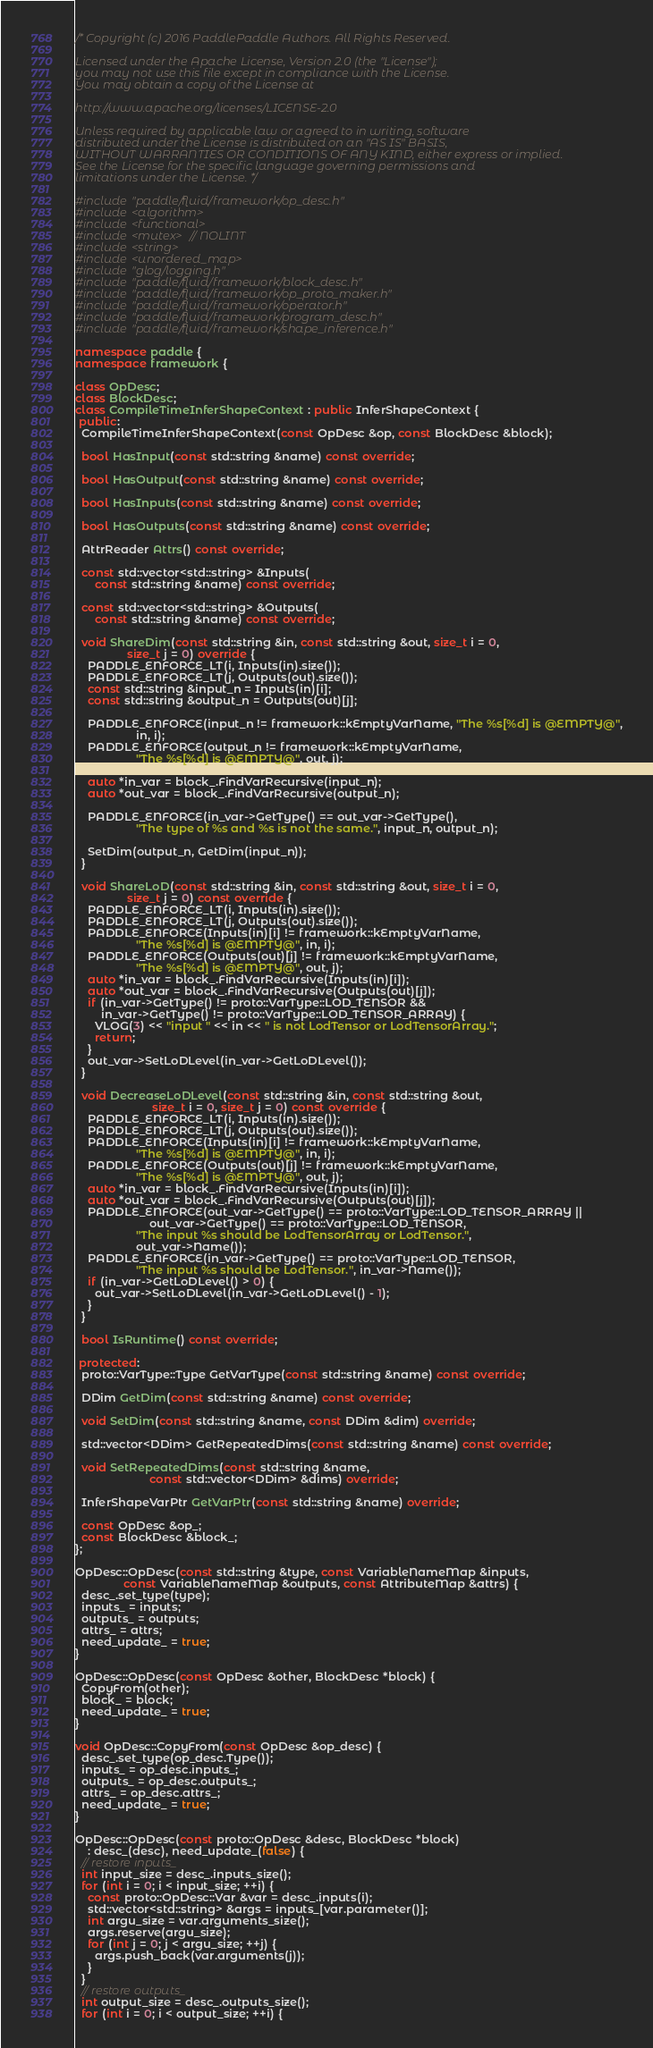<code> <loc_0><loc_0><loc_500><loc_500><_C++_>/* Copyright (c) 2016 PaddlePaddle Authors. All Rights Reserved.

Licensed under the Apache License, Version 2.0 (the "License");
you may not use this file except in compliance with the License.
You may obtain a copy of the License at

http://www.apache.org/licenses/LICENSE-2.0

Unless required by applicable law or agreed to in writing, software
distributed under the License is distributed on an "AS IS" BASIS,
WITHOUT WARRANTIES OR CONDITIONS OF ANY KIND, either express or implied.
See the License for the specific language governing permissions and
limitations under the License. */

#include "paddle/fluid/framework/op_desc.h"
#include <algorithm>
#include <functional>
#include <mutex>  // NOLINT
#include <string>
#include <unordered_map>
#include "glog/logging.h"
#include "paddle/fluid/framework/block_desc.h"
#include "paddle/fluid/framework/op_proto_maker.h"
#include "paddle/fluid/framework/operator.h"
#include "paddle/fluid/framework/program_desc.h"
#include "paddle/fluid/framework/shape_inference.h"

namespace paddle {
namespace framework {

class OpDesc;
class BlockDesc;
class CompileTimeInferShapeContext : public InferShapeContext {
 public:
  CompileTimeInferShapeContext(const OpDesc &op, const BlockDesc &block);

  bool HasInput(const std::string &name) const override;

  bool HasOutput(const std::string &name) const override;

  bool HasInputs(const std::string &name) const override;

  bool HasOutputs(const std::string &name) const override;

  AttrReader Attrs() const override;

  const std::vector<std::string> &Inputs(
      const std::string &name) const override;

  const std::vector<std::string> &Outputs(
      const std::string &name) const override;

  void ShareDim(const std::string &in, const std::string &out, size_t i = 0,
                size_t j = 0) override {
    PADDLE_ENFORCE_LT(i, Inputs(in).size());
    PADDLE_ENFORCE_LT(j, Outputs(out).size());
    const std::string &input_n = Inputs(in)[i];
    const std::string &output_n = Outputs(out)[j];

    PADDLE_ENFORCE(input_n != framework::kEmptyVarName, "The %s[%d] is @EMPTY@",
                   in, i);
    PADDLE_ENFORCE(output_n != framework::kEmptyVarName,
                   "The %s[%d] is @EMPTY@", out, j);

    auto *in_var = block_.FindVarRecursive(input_n);
    auto *out_var = block_.FindVarRecursive(output_n);

    PADDLE_ENFORCE(in_var->GetType() == out_var->GetType(),
                   "The type of %s and %s is not the same.", input_n, output_n);

    SetDim(output_n, GetDim(input_n));
  }

  void ShareLoD(const std::string &in, const std::string &out, size_t i = 0,
                size_t j = 0) const override {
    PADDLE_ENFORCE_LT(i, Inputs(in).size());
    PADDLE_ENFORCE_LT(j, Outputs(out).size());
    PADDLE_ENFORCE(Inputs(in)[i] != framework::kEmptyVarName,
                   "The %s[%d] is @EMPTY@", in, i);
    PADDLE_ENFORCE(Outputs(out)[j] != framework::kEmptyVarName,
                   "The %s[%d] is @EMPTY@", out, j);
    auto *in_var = block_.FindVarRecursive(Inputs(in)[i]);
    auto *out_var = block_.FindVarRecursive(Outputs(out)[j]);
    if (in_var->GetType() != proto::VarType::LOD_TENSOR &&
        in_var->GetType() != proto::VarType::LOD_TENSOR_ARRAY) {
      VLOG(3) << "input " << in << " is not LodTensor or LodTensorArray.";
      return;
    }
    out_var->SetLoDLevel(in_var->GetLoDLevel());
  }

  void DecreaseLoDLevel(const std::string &in, const std::string &out,
                        size_t i = 0, size_t j = 0) const override {
    PADDLE_ENFORCE_LT(i, Inputs(in).size());
    PADDLE_ENFORCE_LT(j, Outputs(out).size());
    PADDLE_ENFORCE(Inputs(in)[i] != framework::kEmptyVarName,
                   "The %s[%d] is @EMPTY@", in, i);
    PADDLE_ENFORCE(Outputs(out)[j] != framework::kEmptyVarName,
                   "The %s[%d] is @EMPTY@", out, j);
    auto *in_var = block_.FindVarRecursive(Inputs(in)[i]);
    auto *out_var = block_.FindVarRecursive(Outputs(out)[j]);
    PADDLE_ENFORCE(out_var->GetType() == proto::VarType::LOD_TENSOR_ARRAY ||
                       out_var->GetType() == proto::VarType::LOD_TENSOR,
                   "The input %s should be LodTensorArray or LodTensor.",
                   out_var->Name());
    PADDLE_ENFORCE(in_var->GetType() == proto::VarType::LOD_TENSOR,
                   "The input %s should be LodTensor.", in_var->Name());
    if (in_var->GetLoDLevel() > 0) {
      out_var->SetLoDLevel(in_var->GetLoDLevel() - 1);
    }
  }

  bool IsRuntime() const override;

 protected:
  proto::VarType::Type GetVarType(const std::string &name) const override;

  DDim GetDim(const std::string &name) const override;

  void SetDim(const std::string &name, const DDim &dim) override;

  std::vector<DDim> GetRepeatedDims(const std::string &name) const override;

  void SetRepeatedDims(const std::string &name,
                       const std::vector<DDim> &dims) override;

  InferShapeVarPtr GetVarPtr(const std::string &name) override;

  const OpDesc &op_;
  const BlockDesc &block_;
};

OpDesc::OpDesc(const std::string &type, const VariableNameMap &inputs,
               const VariableNameMap &outputs, const AttributeMap &attrs) {
  desc_.set_type(type);
  inputs_ = inputs;
  outputs_ = outputs;
  attrs_ = attrs;
  need_update_ = true;
}

OpDesc::OpDesc(const OpDesc &other, BlockDesc *block) {
  CopyFrom(other);
  block_ = block;
  need_update_ = true;
}

void OpDesc::CopyFrom(const OpDesc &op_desc) {
  desc_.set_type(op_desc.Type());
  inputs_ = op_desc.inputs_;
  outputs_ = op_desc.outputs_;
  attrs_ = op_desc.attrs_;
  need_update_ = true;
}

OpDesc::OpDesc(const proto::OpDesc &desc, BlockDesc *block)
    : desc_(desc), need_update_(false) {
  // restore inputs_
  int input_size = desc_.inputs_size();
  for (int i = 0; i < input_size; ++i) {
    const proto::OpDesc::Var &var = desc_.inputs(i);
    std::vector<std::string> &args = inputs_[var.parameter()];
    int argu_size = var.arguments_size();
    args.reserve(argu_size);
    for (int j = 0; j < argu_size; ++j) {
      args.push_back(var.arguments(j));
    }
  }
  // restore outputs_
  int output_size = desc_.outputs_size();
  for (int i = 0; i < output_size; ++i) {</code> 